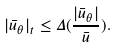<formula> <loc_0><loc_0><loc_500><loc_500>| \bar { u } _ { \theta } | _ { t } \leq \Delta ( \frac { | \bar { u } _ { \theta } | } { \bar { u } } ) .</formula> 